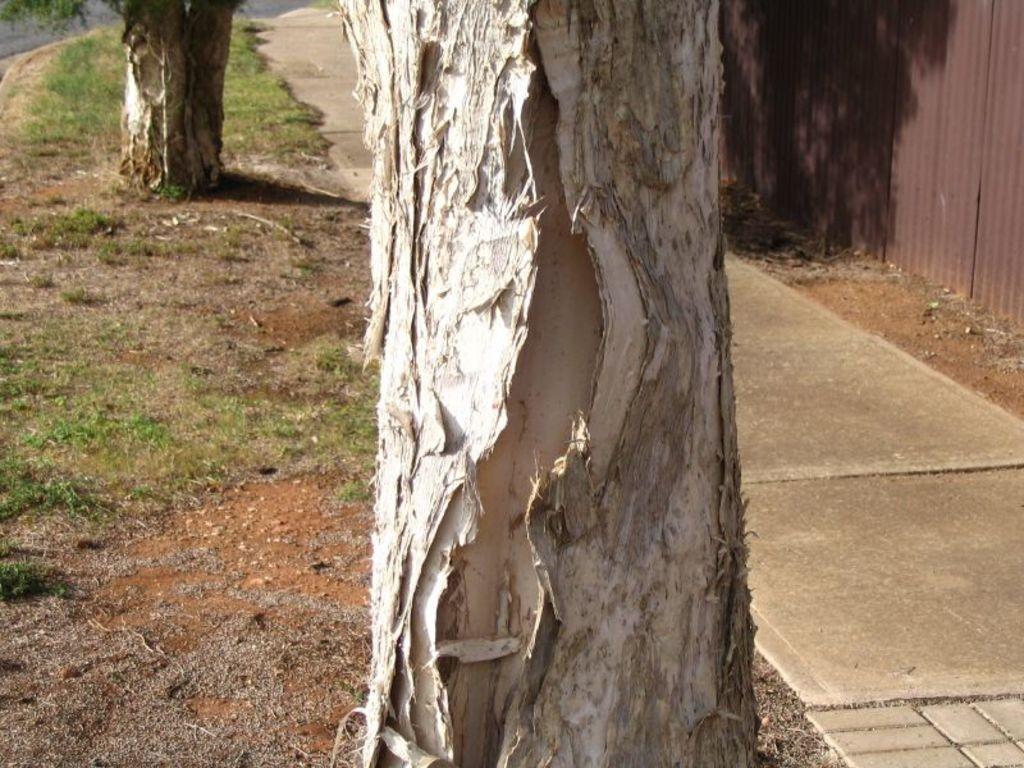Could you give a brief overview of what you see in this image? In this image I can see in the middle it looks like a bark of a tree, on the right side it may be the iron sheet wall. 